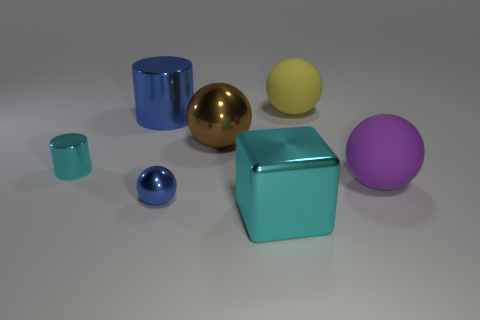Subtract 1 balls. How many balls are left? 3 Add 2 big blue metal objects. How many objects exist? 9 Subtract all balls. How many objects are left? 3 Subtract all big yellow balls. Subtract all big cyan cubes. How many objects are left? 5 Add 1 large spheres. How many large spheres are left? 4 Add 4 tiny gray cylinders. How many tiny gray cylinders exist? 4 Subtract 0 red cylinders. How many objects are left? 7 